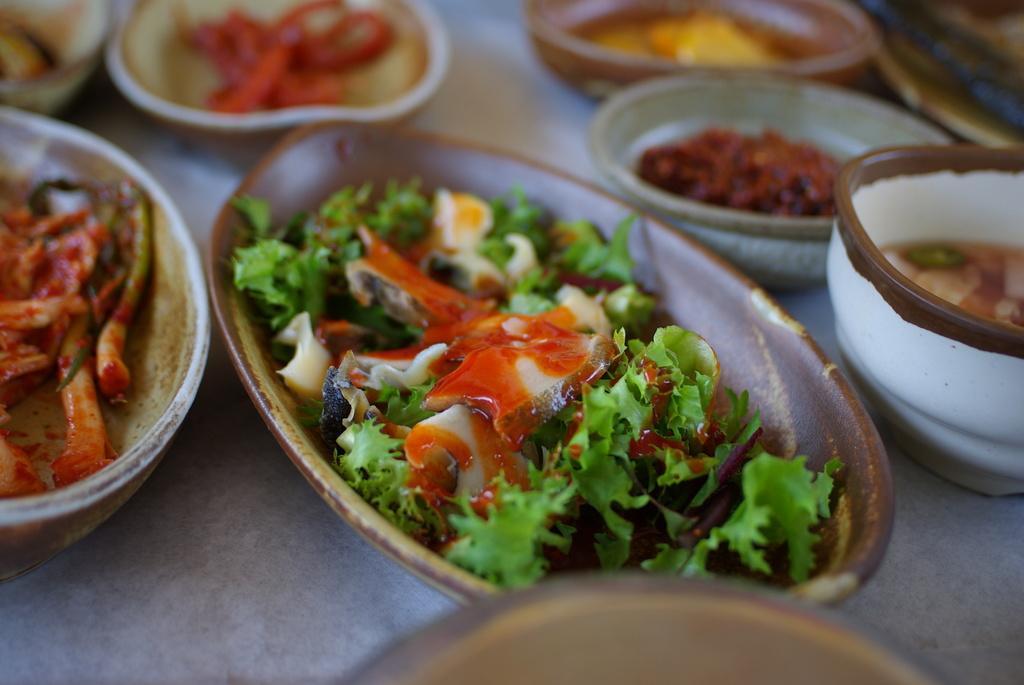In one or two sentences, can you explain what this image depicts? In this image, on the right side, we can see a bowl with some liquid item. On the left side, we can also see another bowl with some food. In the middle of the image, we can see one edge of a plate. In the middle of the image, we can also see a tray with some vegetables. In the background, we can see some bowls with some food items. At the bottom, we can see white color. 